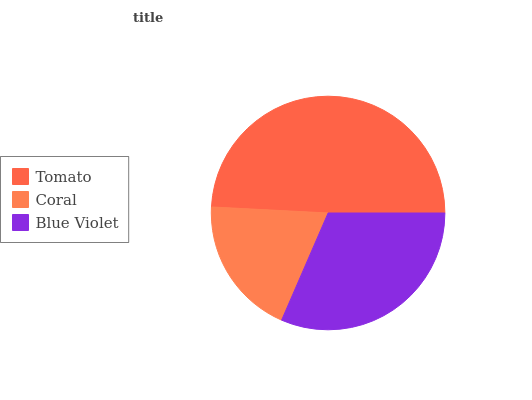Is Coral the minimum?
Answer yes or no. Yes. Is Tomato the maximum?
Answer yes or no. Yes. Is Blue Violet the minimum?
Answer yes or no. No. Is Blue Violet the maximum?
Answer yes or no. No. Is Blue Violet greater than Coral?
Answer yes or no. Yes. Is Coral less than Blue Violet?
Answer yes or no. Yes. Is Coral greater than Blue Violet?
Answer yes or no. No. Is Blue Violet less than Coral?
Answer yes or no. No. Is Blue Violet the high median?
Answer yes or no. Yes. Is Blue Violet the low median?
Answer yes or no. Yes. Is Coral the high median?
Answer yes or no. No. Is Tomato the low median?
Answer yes or no. No. 